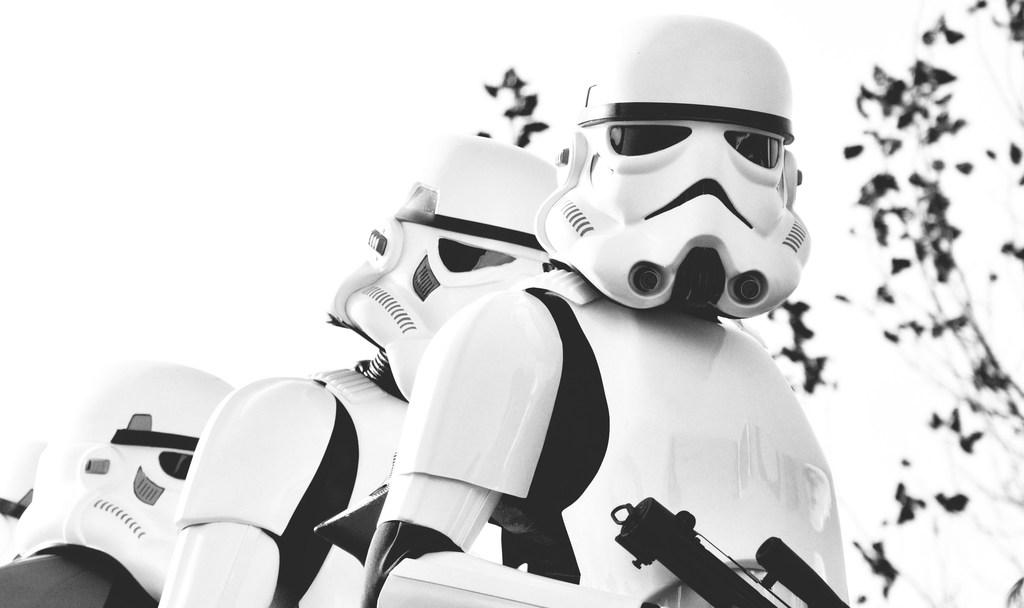What is the color scheme of the image? The image is black and white. What type of objects can be seen in the image? There are robots and plants in the image. Are there any objects that might be used as a weapon in the image? Yes, there is a gun in the image. How comfortable are the sand dunes in the image? There are no sand dunes present in the image; it features robots, plants, and a gun. What type of pen is being used to draw the robots in the image? There is no pen or drawing activity depicted in the image; it is a photograph or illustration of robots, plants, and a gun. 